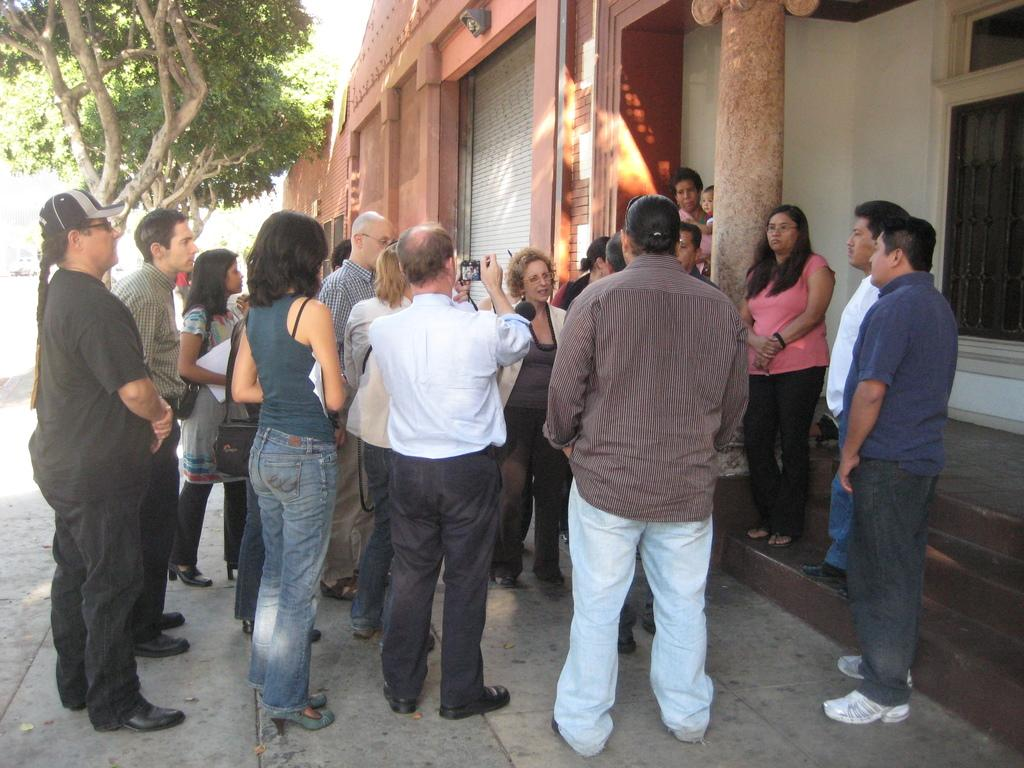What is happening in the image? There is a group of people standing in the image. What can be seen on the left side of the image? There are green trees on the left side of the image. What type of structure is present in the image? There is a house in the image. What is the hen's purpose in the image? There is no hen present in the image, so it is not possible to determine its purpose. 